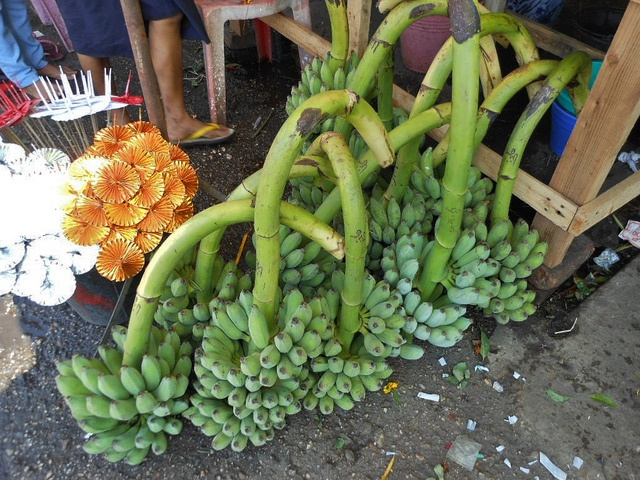Describe the objects in this image and their specific colors. I can see banana in navy, green, olive, and darkgreen tones, banana in navy, green, darkgreen, and darkgray tones, people in navy, gray, black, and maroon tones, banana in navy, green, turquoise, and darkgreen tones, and banana in navy, green, and darkgreen tones in this image. 